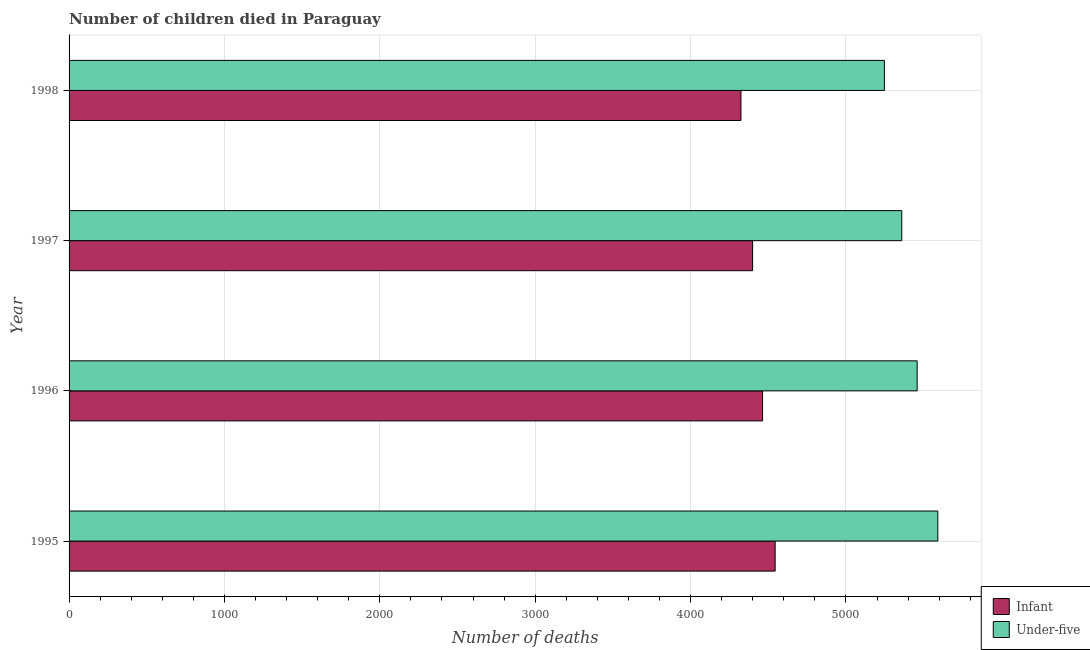How many different coloured bars are there?
Ensure brevity in your answer.  2. How many groups of bars are there?
Your answer should be very brief. 4. Are the number of bars per tick equal to the number of legend labels?
Provide a succinct answer. Yes. How many bars are there on the 2nd tick from the bottom?
Provide a succinct answer. 2. What is the number of infant deaths in 1997?
Your answer should be compact. 4399. Across all years, what is the maximum number of under-five deaths?
Ensure brevity in your answer.  5591. Across all years, what is the minimum number of under-five deaths?
Ensure brevity in your answer.  5247. In which year was the number of infant deaths maximum?
Provide a succinct answer. 1995. In which year was the number of under-five deaths minimum?
Offer a very short reply. 1998. What is the total number of under-five deaths in the graph?
Your answer should be compact. 2.17e+04. What is the difference between the number of under-five deaths in 1995 and that in 1998?
Your answer should be very brief. 344. What is the difference between the number of infant deaths in 1995 and the number of under-five deaths in 1996?
Give a very brief answer. -914. What is the average number of under-five deaths per year?
Keep it short and to the point. 5413.75. In the year 1997, what is the difference between the number of under-five deaths and number of infant deaths?
Offer a very short reply. 960. In how many years, is the number of under-five deaths greater than 1600 ?
Keep it short and to the point. 4. What is the ratio of the number of infant deaths in 1996 to that in 1997?
Provide a succinct answer. 1.01. Is the number of infant deaths in 1995 less than that in 1998?
Provide a short and direct response. No. What is the difference between the highest and the second highest number of under-five deaths?
Provide a succinct answer. 133. What is the difference between the highest and the lowest number of under-five deaths?
Provide a succinct answer. 344. What does the 2nd bar from the top in 1996 represents?
Your answer should be compact. Infant. What does the 1st bar from the bottom in 1996 represents?
Your response must be concise. Infant. How many bars are there?
Keep it short and to the point. 8. How many years are there in the graph?
Your answer should be very brief. 4. What is the difference between two consecutive major ticks on the X-axis?
Your answer should be compact. 1000. Does the graph contain grids?
Ensure brevity in your answer.  Yes. Where does the legend appear in the graph?
Offer a terse response. Bottom right. How are the legend labels stacked?
Your response must be concise. Vertical. What is the title of the graph?
Keep it short and to the point. Number of children died in Paraguay. Does "Young" appear as one of the legend labels in the graph?
Make the answer very short. No. What is the label or title of the X-axis?
Your answer should be very brief. Number of deaths. What is the Number of deaths of Infant in 1995?
Offer a very short reply. 4544. What is the Number of deaths in Under-five in 1995?
Offer a very short reply. 5591. What is the Number of deaths in Infant in 1996?
Offer a terse response. 4463. What is the Number of deaths of Under-five in 1996?
Provide a short and direct response. 5458. What is the Number of deaths in Infant in 1997?
Your response must be concise. 4399. What is the Number of deaths in Under-five in 1997?
Offer a terse response. 5359. What is the Number of deaths of Infant in 1998?
Provide a succinct answer. 4324. What is the Number of deaths of Under-five in 1998?
Give a very brief answer. 5247. Across all years, what is the maximum Number of deaths in Infant?
Your answer should be compact. 4544. Across all years, what is the maximum Number of deaths of Under-five?
Your answer should be compact. 5591. Across all years, what is the minimum Number of deaths in Infant?
Your answer should be very brief. 4324. Across all years, what is the minimum Number of deaths in Under-five?
Keep it short and to the point. 5247. What is the total Number of deaths in Infant in the graph?
Offer a very short reply. 1.77e+04. What is the total Number of deaths in Under-five in the graph?
Provide a short and direct response. 2.17e+04. What is the difference between the Number of deaths in Infant in 1995 and that in 1996?
Your answer should be compact. 81. What is the difference between the Number of deaths of Under-five in 1995 and that in 1996?
Provide a succinct answer. 133. What is the difference between the Number of deaths of Infant in 1995 and that in 1997?
Ensure brevity in your answer.  145. What is the difference between the Number of deaths of Under-five in 1995 and that in 1997?
Give a very brief answer. 232. What is the difference between the Number of deaths of Infant in 1995 and that in 1998?
Provide a succinct answer. 220. What is the difference between the Number of deaths in Under-five in 1995 and that in 1998?
Keep it short and to the point. 344. What is the difference between the Number of deaths in Infant in 1996 and that in 1997?
Offer a very short reply. 64. What is the difference between the Number of deaths in Under-five in 1996 and that in 1997?
Ensure brevity in your answer.  99. What is the difference between the Number of deaths of Infant in 1996 and that in 1998?
Ensure brevity in your answer.  139. What is the difference between the Number of deaths of Under-five in 1996 and that in 1998?
Provide a short and direct response. 211. What is the difference between the Number of deaths in Infant in 1997 and that in 1998?
Your answer should be compact. 75. What is the difference between the Number of deaths of Under-five in 1997 and that in 1998?
Make the answer very short. 112. What is the difference between the Number of deaths in Infant in 1995 and the Number of deaths in Under-five in 1996?
Make the answer very short. -914. What is the difference between the Number of deaths in Infant in 1995 and the Number of deaths in Under-five in 1997?
Ensure brevity in your answer.  -815. What is the difference between the Number of deaths in Infant in 1995 and the Number of deaths in Under-five in 1998?
Give a very brief answer. -703. What is the difference between the Number of deaths of Infant in 1996 and the Number of deaths of Under-five in 1997?
Provide a short and direct response. -896. What is the difference between the Number of deaths in Infant in 1996 and the Number of deaths in Under-five in 1998?
Your answer should be compact. -784. What is the difference between the Number of deaths in Infant in 1997 and the Number of deaths in Under-five in 1998?
Offer a terse response. -848. What is the average Number of deaths of Infant per year?
Your answer should be very brief. 4432.5. What is the average Number of deaths of Under-five per year?
Provide a succinct answer. 5413.75. In the year 1995, what is the difference between the Number of deaths in Infant and Number of deaths in Under-five?
Provide a succinct answer. -1047. In the year 1996, what is the difference between the Number of deaths in Infant and Number of deaths in Under-five?
Provide a short and direct response. -995. In the year 1997, what is the difference between the Number of deaths of Infant and Number of deaths of Under-five?
Offer a terse response. -960. In the year 1998, what is the difference between the Number of deaths in Infant and Number of deaths in Under-five?
Offer a terse response. -923. What is the ratio of the Number of deaths of Infant in 1995 to that in 1996?
Your answer should be very brief. 1.02. What is the ratio of the Number of deaths of Under-five in 1995 to that in 1996?
Your answer should be compact. 1.02. What is the ratio of the Number of deaths of Infant in 1995 to that in 1997?
Offer a terse response. 1.03. What is the ratio of the Number of deaths of Under-five in 1995 to that in 1997?
Provide a short and direct response. 1.04. What is the ratio of the Number of deaths in Infant in 1995 to that in 1998?
Offer a terse response. 1.05. What is the ratio of the Number of deaths of Under-five in 1995 to that in 1998?
Provide a succinct answer. 1.07. What is the ratio of the Number of deaths in Infant in 1996 to that in 1997?
Provide a succinct answer. 1.01. What is the ratio of the Number of deaths in Under-five in 1996 to that in 1997?
Offer a very short reply. 1.02. What is the ratio of the Number of deaths in Infant in 1996 to that in 1998?
Offer a very short reply. 1.03. What is the ratio of the Number of deaths in Under-five in 1996 to that in 1998?
Provide a succinct answer. 1.04. What is the ratio of the Number of deaths of Infant in 1997 to that in 1998?
Your response must be concise. 1.02. What is the ratio of the Number of deaths of Under-five in 1997 to that in 1998?
Keep it short and to the point. 1.02. What is the difference between the highest and the second highest Number of deaths in Under-five?
Your answer should be very brief. 133. What is the difference between the highest and the lowest Number of deaths of Infant?
Provide a short and direct response. 220. What is the difference between the highest and the lowest Number of deaths of Under-five?
Offer a terse response. 344. 